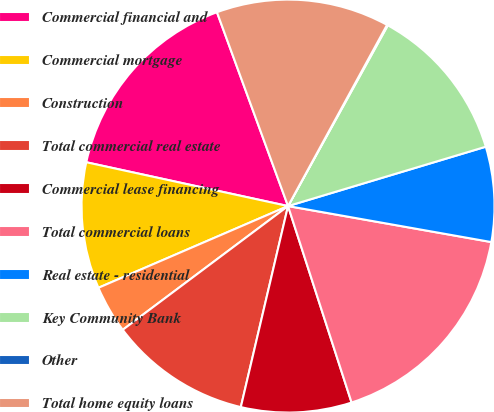<chart> <loc_0><loc_0><loc_500><loc_500><pie_chart><fcel>Commercial financial and<fcel>Commercial mortgage<fcel>Construction<fcel>Total commercial real estate<fcel>Commercial lease financing<fcel>Total commercial loans<fcel>Real estate - residential<fcel>Key Community Bank<fcel>Other<fcel>Total home equity loans<nl><fcel>16.0%<fcel>9.88%<fcel>3.75%<fcel>11.1%<fcel>8.65%<fcel>17.23%<fcel>7.43%<fcel>12.33%<fcel>0.07%<fcel>13.55%<nl></chart> 